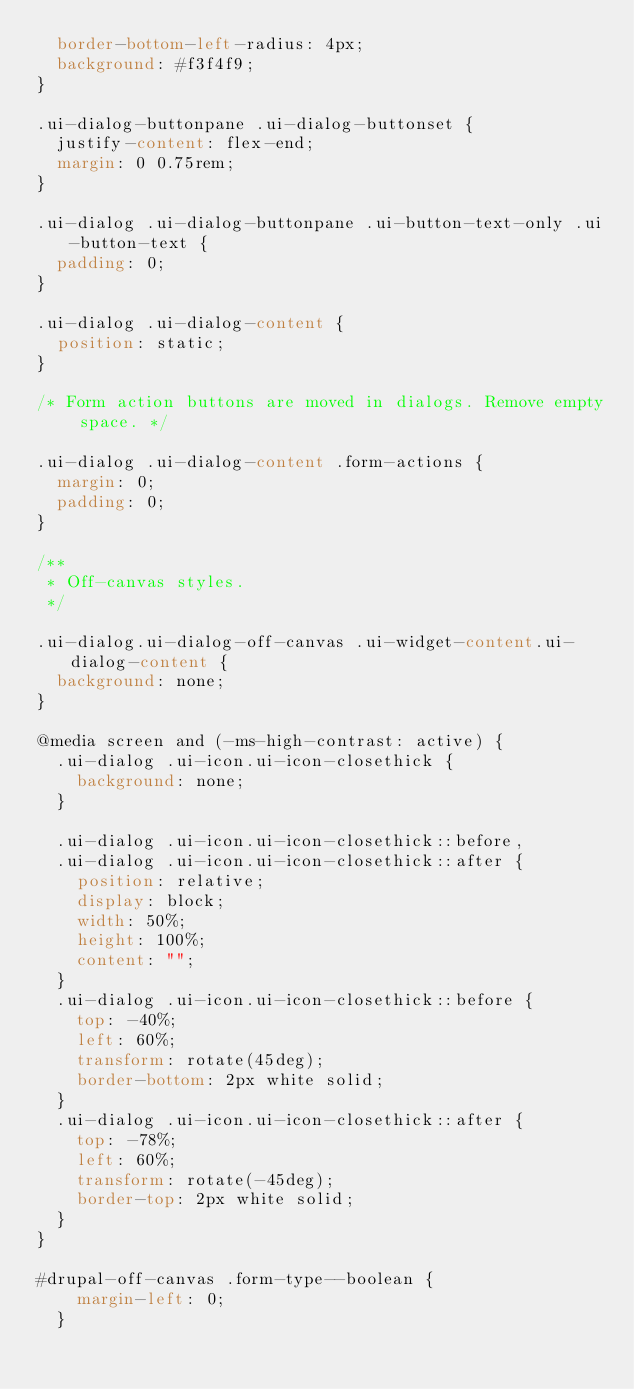<code> <loc_0><loc_0><loc_500><loc_500><_CSS_>  border-bottom-left-radius: 4px;
  background: #f3f4f9;
}

.ui-dialog-buttonpane .ui-dialog-buttonset {
  justify-content: flex-end;
  margin: 0 0.75rem;
}

.ui-dialog .ui-dialog-buttonpane .ui-button-text-only .ui-button-text {
  padding: 0;
}

.ui-dialog .ui-dialog-content {
  position: static;
}

/* Form action buttons are moved in dialogs. Remove empty space. */

.ui-dialog .ui-dialog-content .form-actions {
  margin: 0;
  padding: 0;
}

/**
 * Off-canvas styles.
 */

.ui-dialog.ui-dialog-off-canvas .ui-widget-content.ui-dialog-content {
  background: none;
}

@media screen and (-ms-high-contrast: active) {
  .ui-dialog .ui-icon.ui-icon-closethick {
    background: none;
  }

  .ui-dialog .ui-icon.ui-icon-closethick::before,
  .ui-dialog .ui-icon.ui-icon-closethick::after {
    position: relative;
    display: block;
    width: 50%;
    height: 100%;
    content: "";
  }
  .ui-dialog .ui-icon.ui-icon-closethick::before {
    top: -40%;
    left: 60%;
    transform: rotate(45deg);
    border-bottom: 2px white solid;
  }
  .ui-dialog .ui-icon.ui-icon-closethick::after {
    top: -78%;
    left: 60%;
    transform: rotate(-45deg);
    border-top: 2px white solid;
  }
}

#drupal-off-canvas .form-type--boolean {
    margin-left: 0;
  }
</code> 